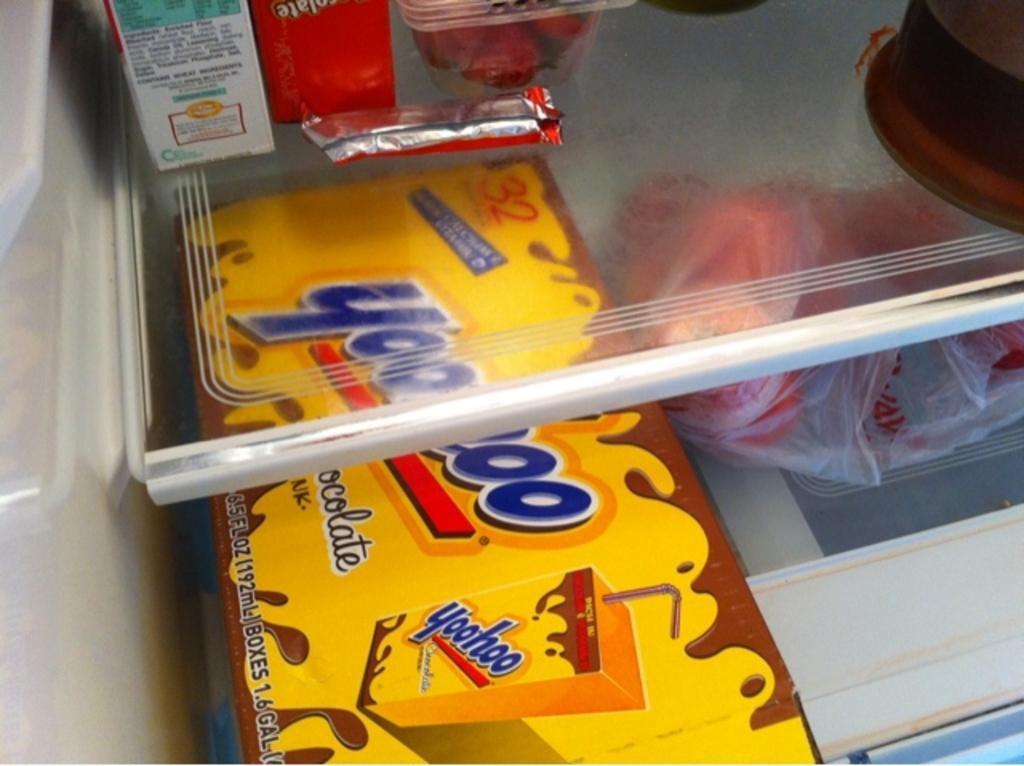What is one of the objects in the image? There is a box in the image. What else can be seen in the image? There are cartons and a cover in the image. Where are the box, cartons, and cover located? They are placed in a refrigerator. What type of yarn is being used by the rat in the image? There is no rat or yarn present in the image. 